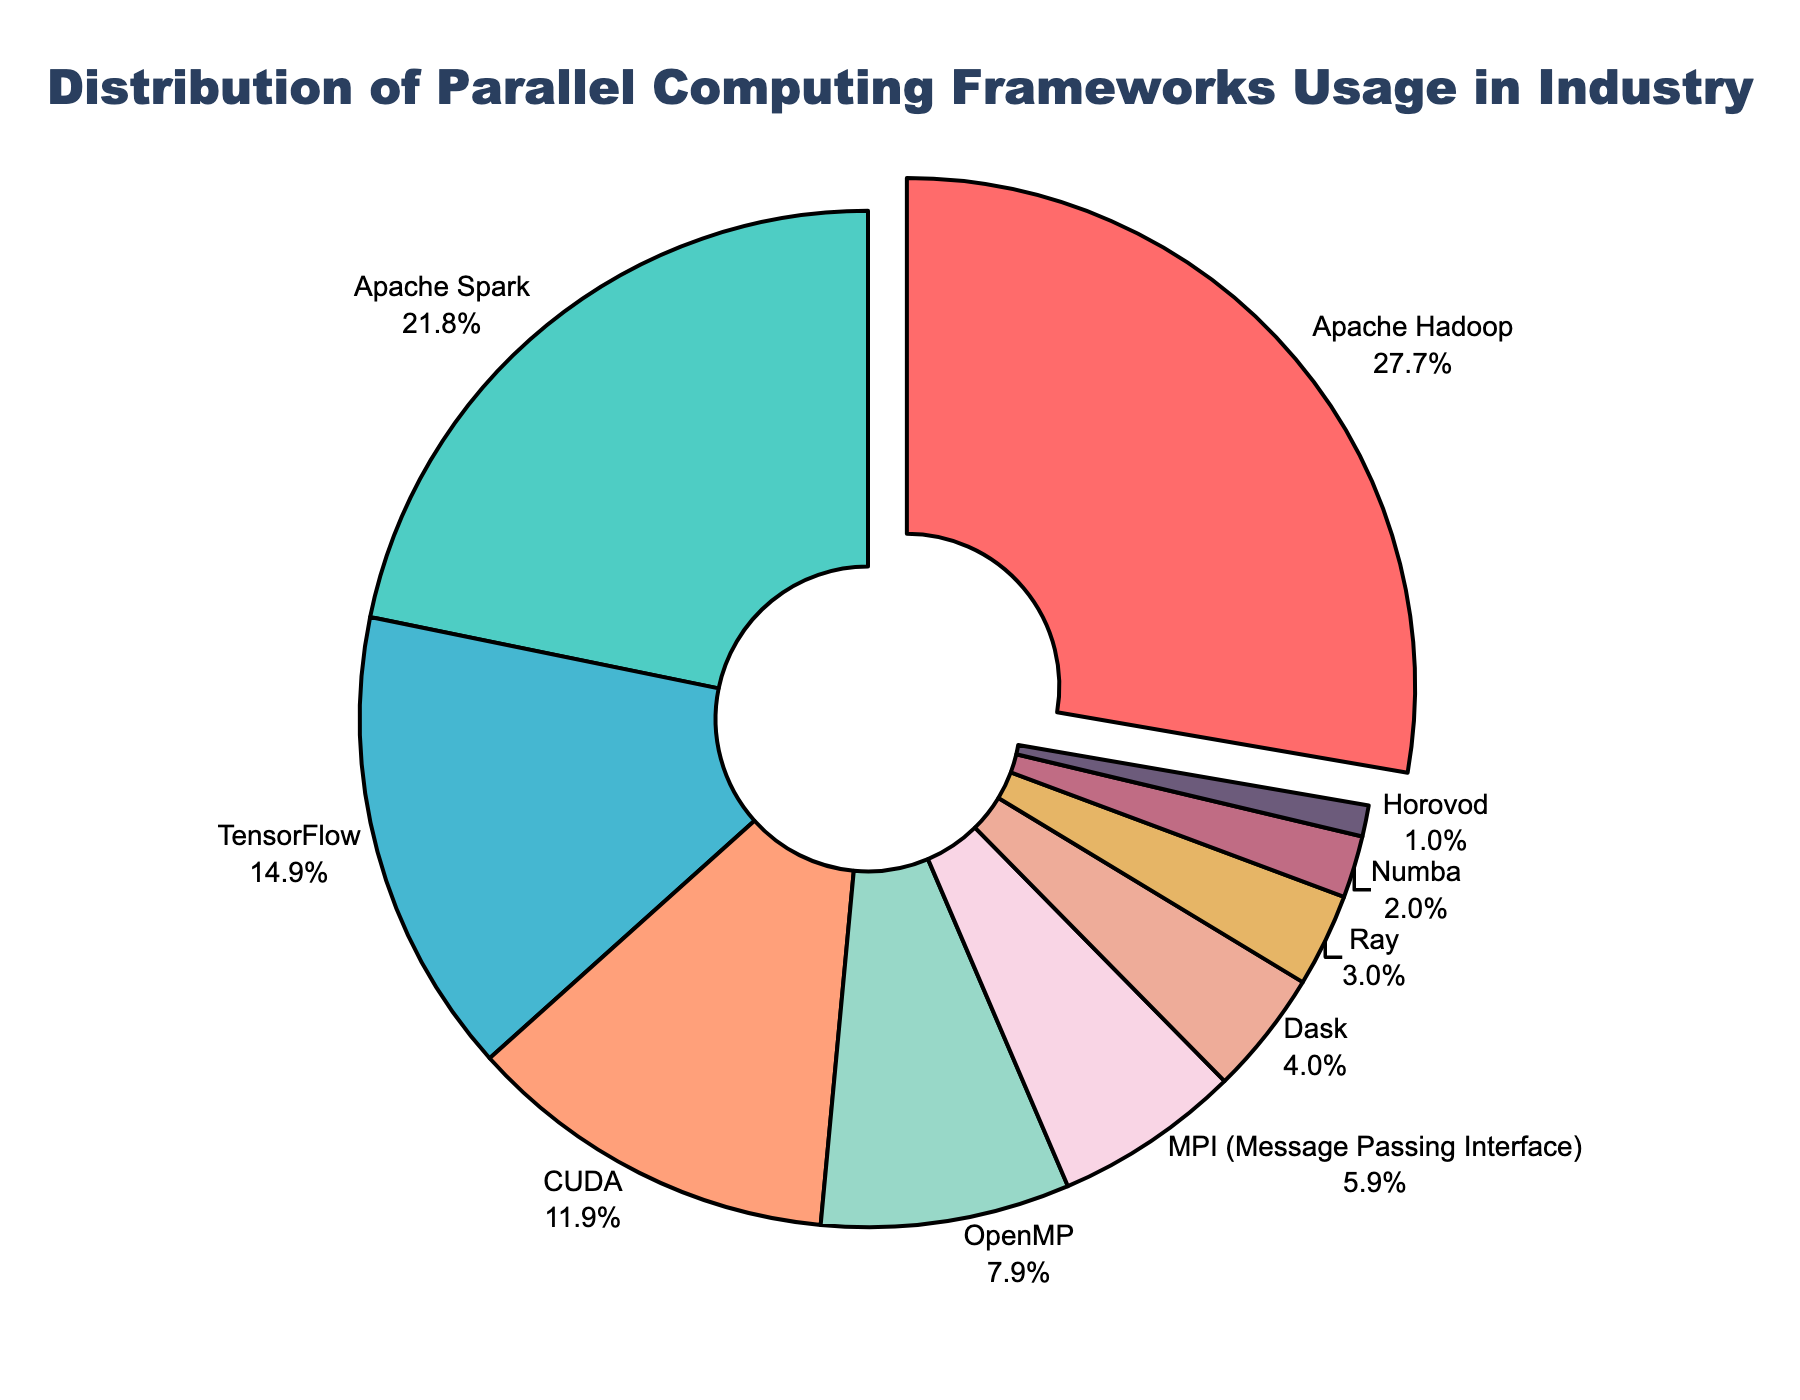What percentage of the distribution does Apache Hadoop cover? Apache Hadoop covers 28% of the distribution as indicated by its label on the pie chart.
Answer: 28% Which framework has the second highest usage percentage in the industry? The pie chart shows that Apache Spark, comprising 22%, is the framework with the second highest usage after Apache Hadoop.
Answer: Apache Spark How much more usage percentage does Apache Hadoop have compared to CUDA? Apache Hadoop has 28% and CUDA has 12%. The difference in their usage percentages is 28 - 12 = 16%.
Answer: 16% What is the combined usage percentage of TensorFlow, OpenMP, and MPI? Summing the percentages: TensorFlow (15%) + OpenMP (8%) + MPI (6%) = 15 + 8 + 6 = 29%.
Answer: 29% Which framework has the least usage and what is its percentage? The framework with the least usage is Horovod, with a usage percentage of 1% as evident from the pie chart.
Answer: Horovod, 1% Is the combined usage of Apache Spark and TensorFlow greater than that of Apache Hadoop? Combining Apache Spark (22%) and TensorFlow (15%) gives 22 + 15 = 37%, which is greater than Apache Hadoop's 28%.
Answer: Yes What color represents CUDA in the pie chart? CUDA is represented by a yellowish-orange section in the pie chart.
Answer: Yellowish-orange Calculate the average percentage of usage of CUDA, OpenMP, and Dask combined. Adding CUDA (12%), OpenMP (8%), and Dask (4%) gives 12 + 8 + 4 = 24%. The average is then 24 / 3 = 8%.
Answer: 8% Which framework has a slightly lower percentage usage than OpenMP and what is its usage percentage? MPI has a slightly lower usage percentage than OpenMP. MPI has 6% while OpenMP has 8%.
Answer: MPI, 6% What is the difference in usage percentage between Dask and Ray? Dask has 4% and Ray has 3%. The difference is 4 - 3 = 1%.
Answer: 1% 